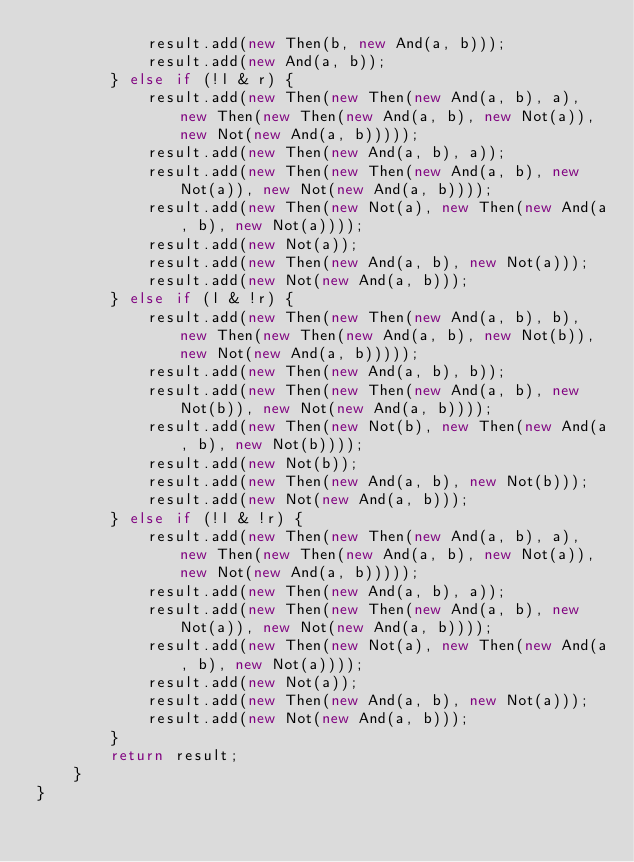<code> <loc_0><loc_0><loc_500><loc_500><_Java_>            result.add(new Then(b, new And(a, b)));
            result.add(new And(a, b));
        } else if (!l & r) {
            result.add(new Then(new Then(new And(a, b), a), new Then(new Then(new And(a, b), new Not(a)), new Not(new And(a, b)))));
            result.add(new Then(new And(a, b), a));
            result.add(new Then(new Then(new And(a, b), new Not(a)), new Not(new And(a, b))));
            result.add(new Then(new Not(a), new Then(new And(a, b), new Not(a))));
            result.add(new Not(a));
            result.add(new Then(new And(a, b), new Not(a)));
            result.add(new Not(new And(a, b)));
        } else if (l & !r) {
            result.add(new Then(new Then(new And(a, b), b), new Then(new Then(new And(a, b), new Not(b)), new Not(new And(a, b)))));
            result.add(new Then(new And(a, b), b));
            result.add(new Then(new Then(new And(a, b), new Not(b)), new Not(new And(a, b))));
            result.add(new Then(new Not(b), new Then(new And(a, b), new Not(b))));
            result.add(new Not(b));
            result.add(new Then(new And(a, b), new Not(b)));
            result.add(new Not(new And(a, b)));
        } else if (!l & !r) {
            result.add(new Then(new Then(new And(a, b), a), new Then(new Then(new And(a, b), new Not(a)), new Not(new And(a, b)))));
            result.add(new Then(new And(a, b), a));
            result.add(new Then(new Then(new And(a, b), new Not(a)), new Not(new And(a, b))));
            result.add(new Then(new Not(a), new Then(new And(a, b), new Not(a))));
            result.add(new Not(a));
            result.add(new Then(new And(a, b), new Not(a)));
            result.add(new Not(new And(a, b)));
        }
        return result;
    }
}
</code> 